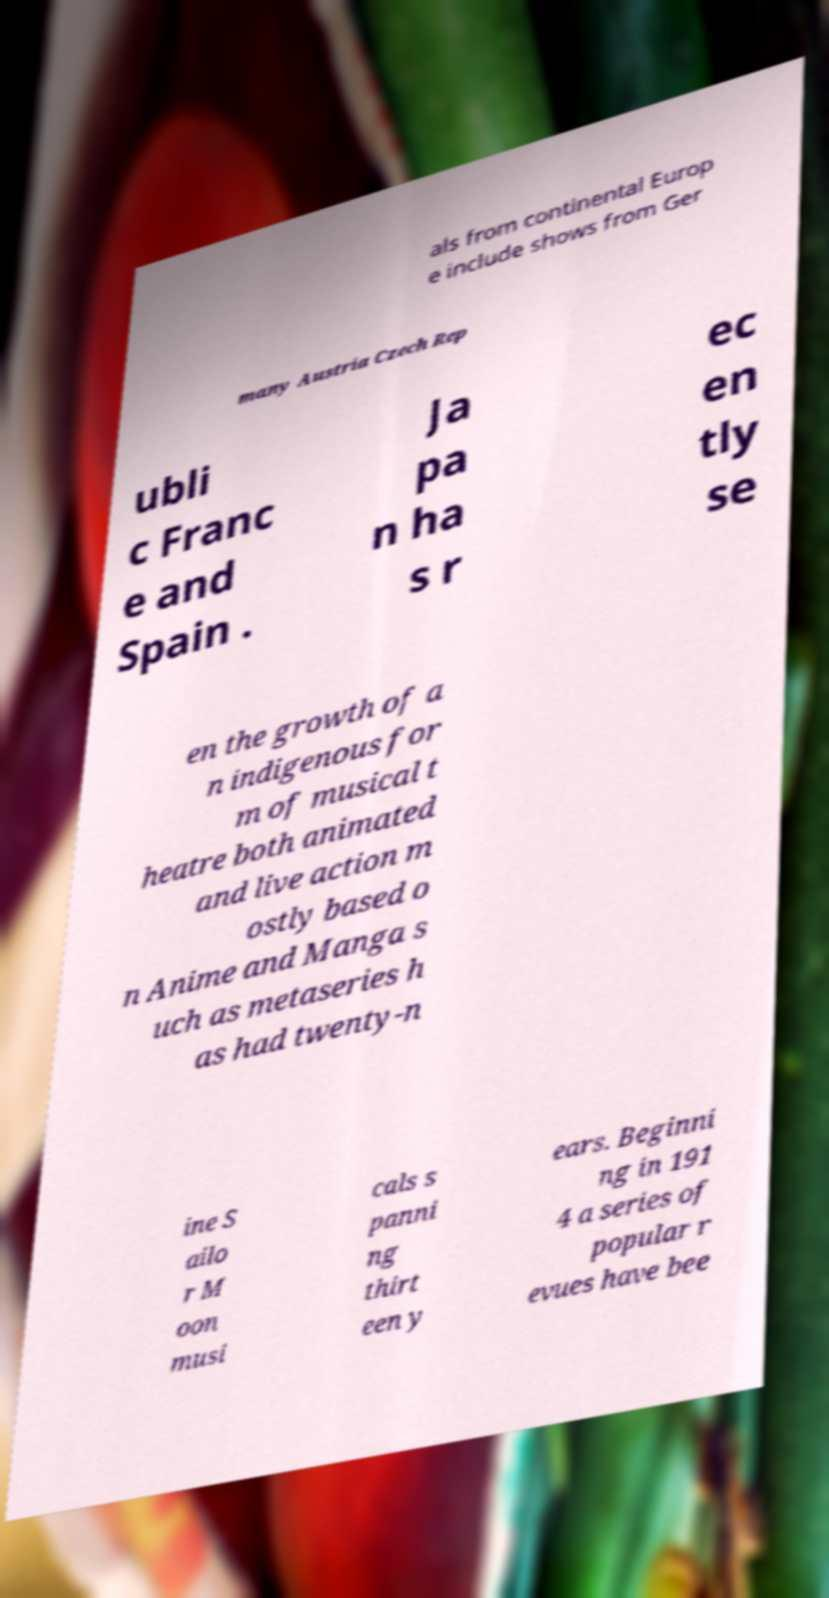There's text embedded in this image that I need extracted. Can you transcribe it verbatim? als from continental Europ e include shows from Ger many Austria Czech Rep ubli c Franc e and Spain . Ja pa n ha s r ec en tly se en the growth of a n indigenous for m of musical t heatre both animated and live action m ostly based o n Anime and Manga s uch as metaseries h as had twenty-n ine S ailo r M oon musi cals s panni ng thirt een y ears. Beginni ng in 191 4 a series of popular r evues have bee 